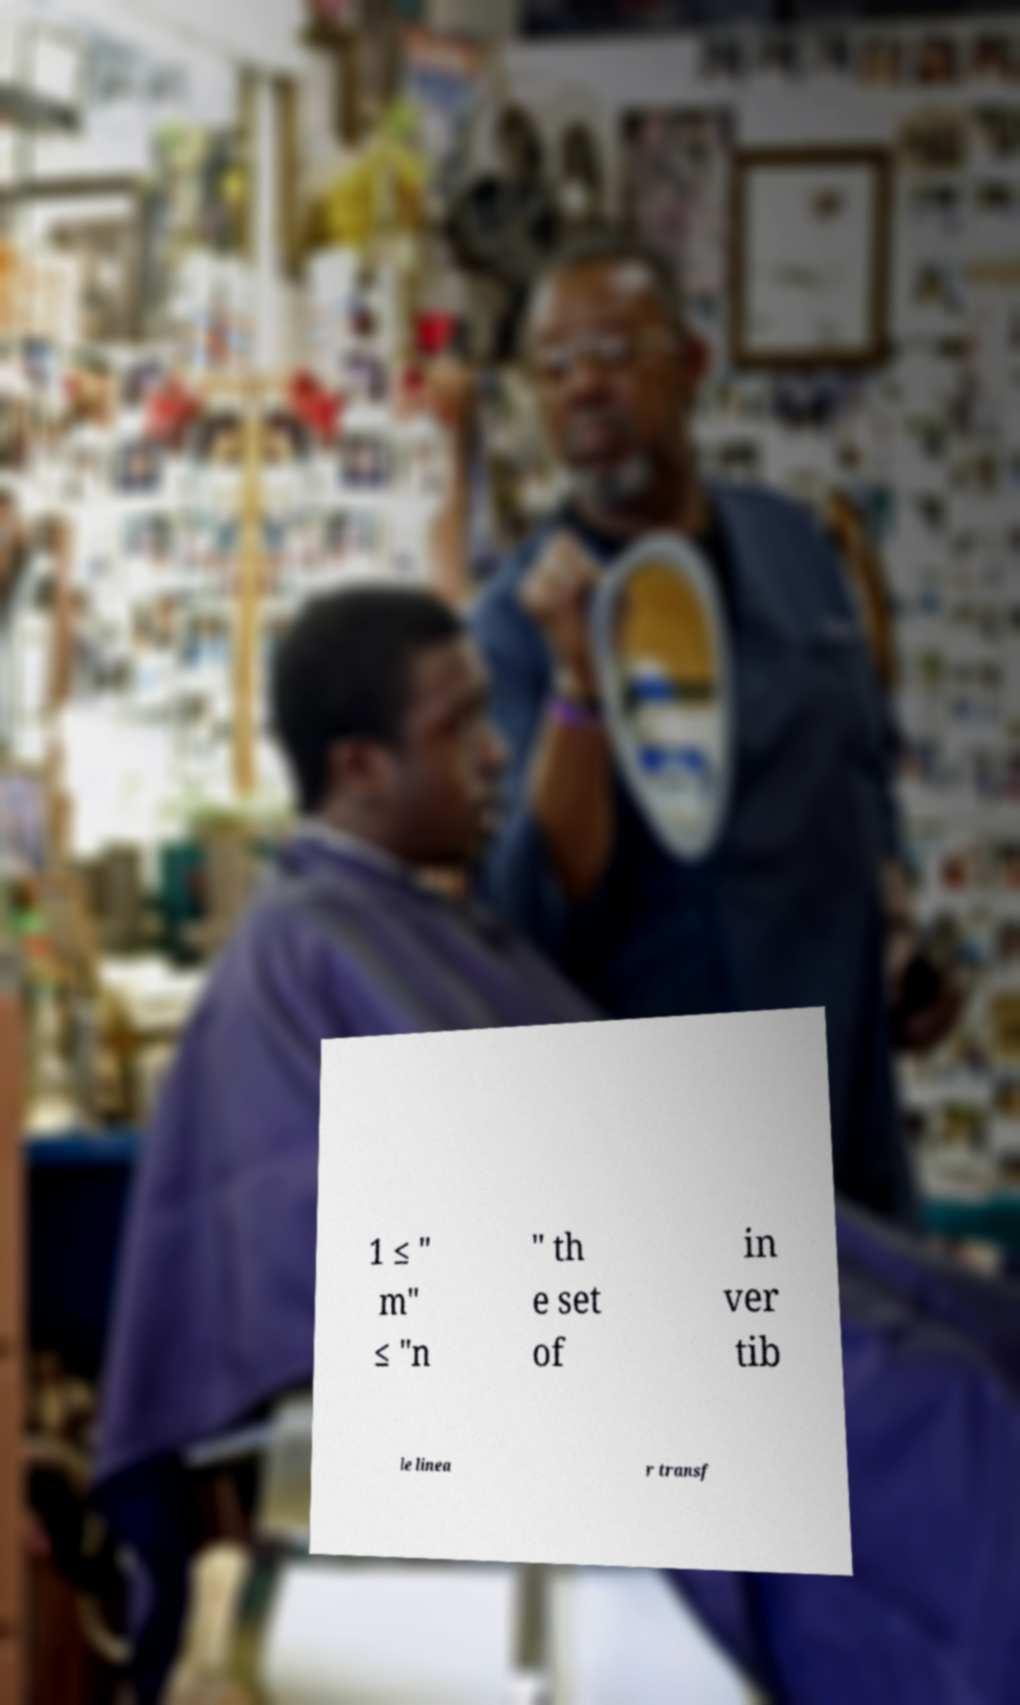Please read and relay the text visible in this image. What does it say? 1 ≤ " m" ≤ "n " th e set of in ver tib le linea r transf 